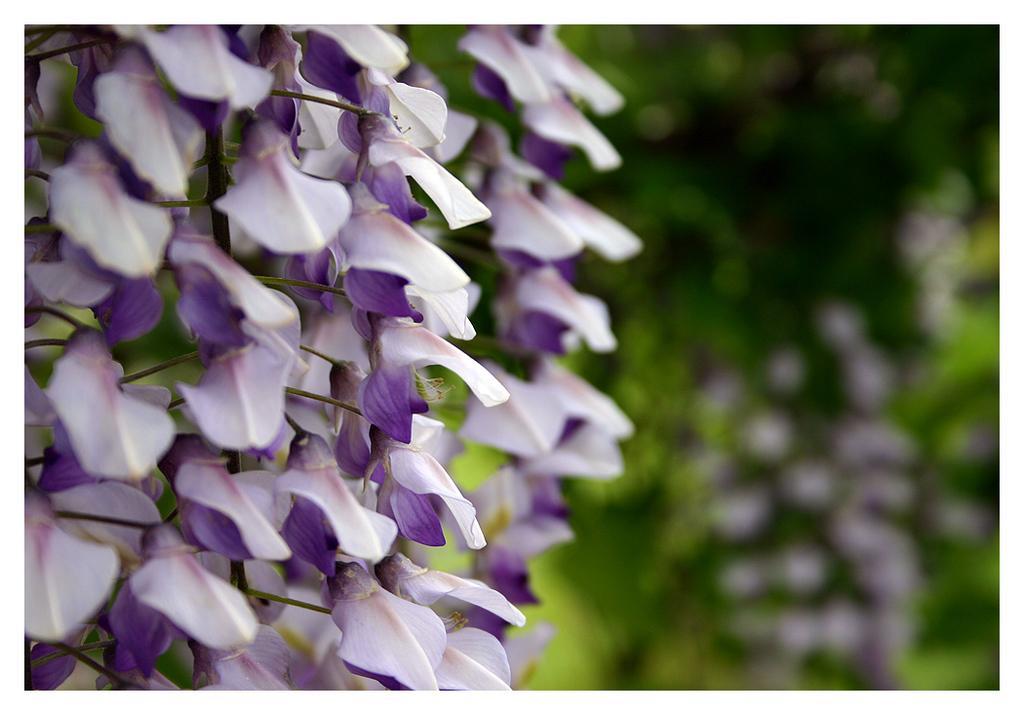How would you summarize this image in a sentence or two? In this image there are flowers. 